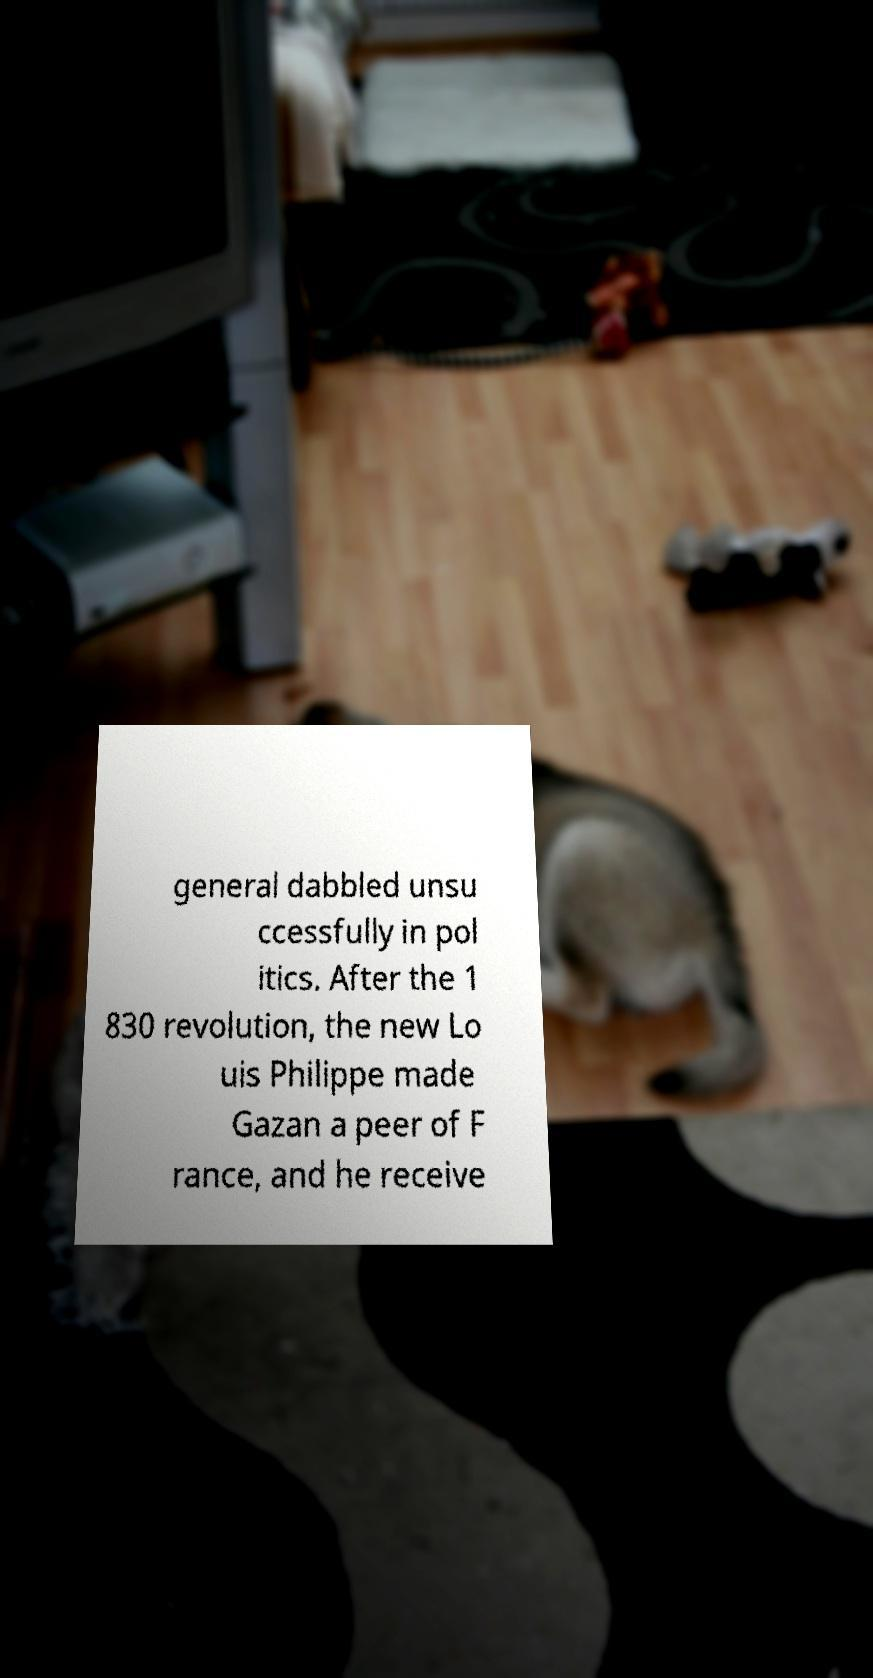Can you read and provide the text displayed in the image?This photo seems to have some interesting text. Can you extract and type it out for me? general dabbled unsu ccessfully in pol itics. After the 1 830 revolution, the new Lo uis Philippe made Gazan a peer of F rance, and he receive 